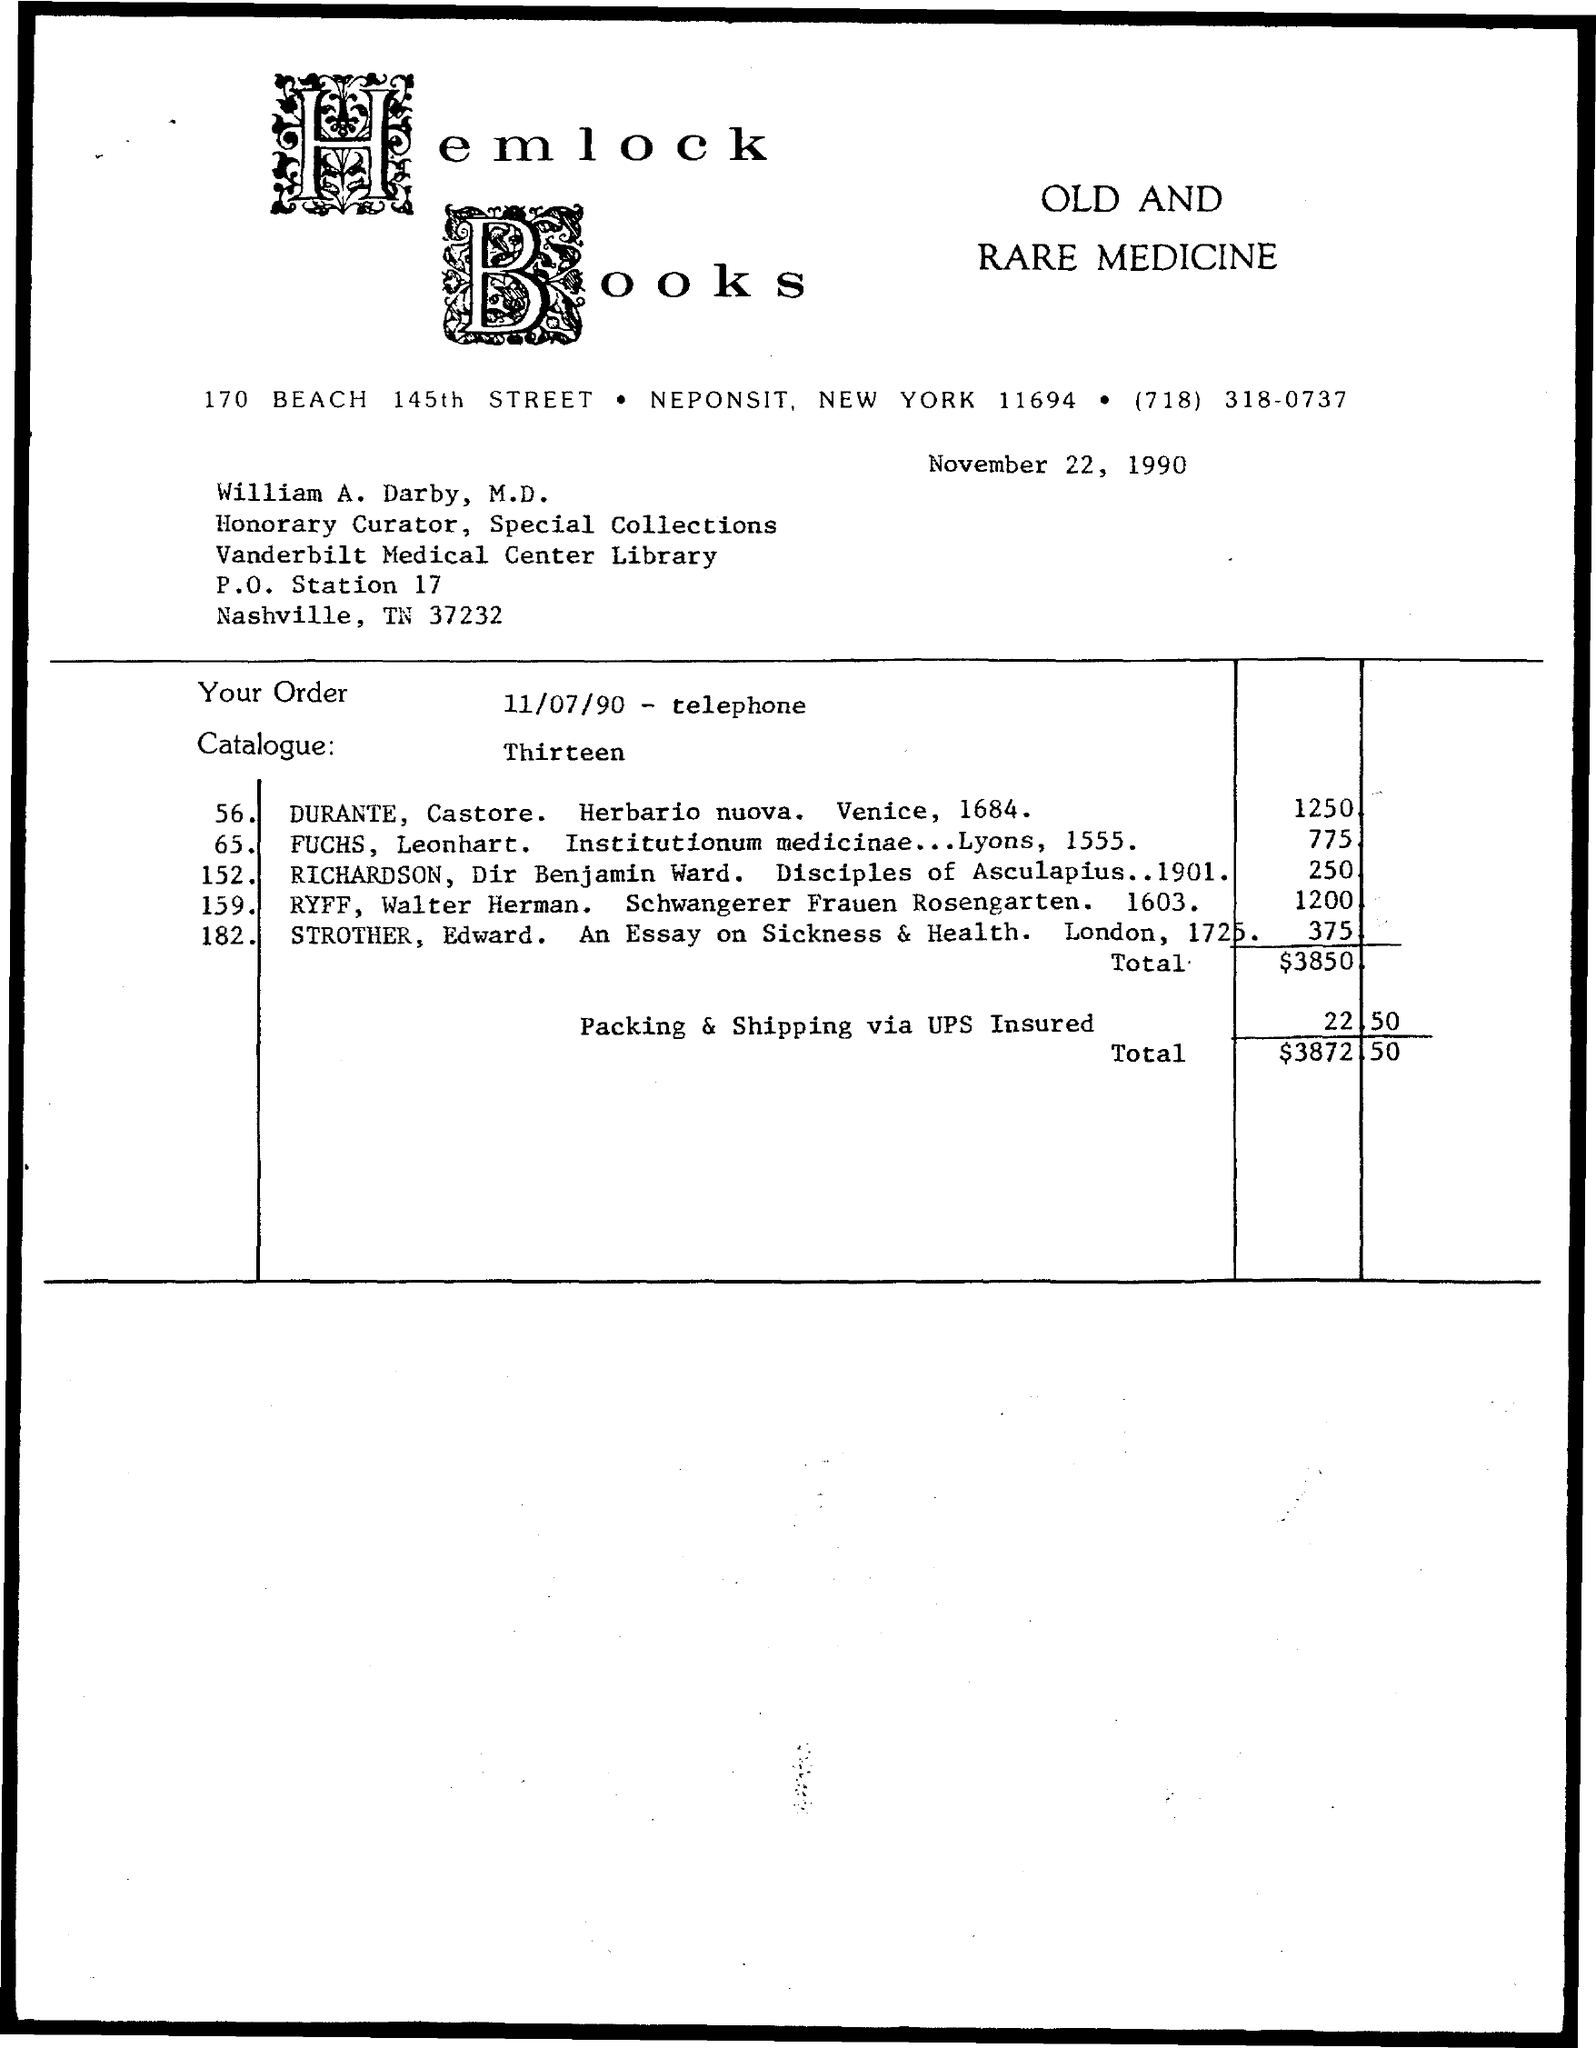Draw attention to some important aspects in this diagram. The total amount mentioned on the given page is $3,872.50. The amount for packing and shipping via UPS insured is $22.50. 